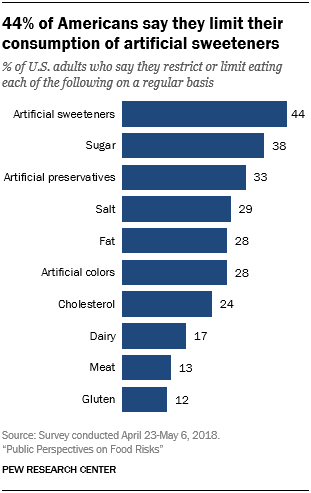Give some essential details in this illustration. The value of dairy, fat, and gluten is greater than the sugar in the graph. Artificial sweeteners have been found to have a value of 44. 